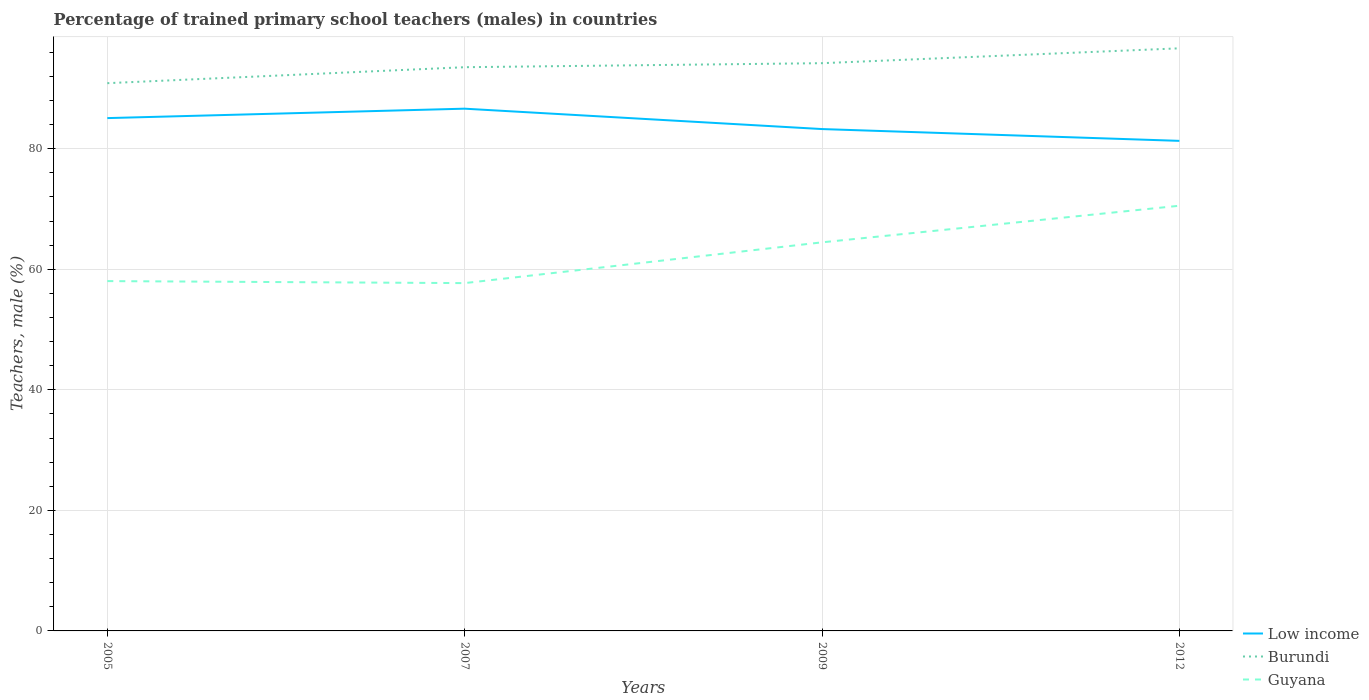Does the line corresponding to Burundi intersect with the line corresponding to Guyana?
Provide a succinct answer. No. Is the number of lines equal to the number of legend labels?
Ensure brevity in your answer.  Yes. Across all years, what is the maximum percentage of trained primary school teachers (males) in Low income?
Offer a very short reply. 81.31. What is the total percentage of trained primary school teachers (males) in Guyana in the graph?
Make the answer very short. -12.5. What is the difference between the highest and the second highest percentage of trained primary school teachers (males) in Burundi?
Provide a short and direct response. 5.78. What is the difference between the highest and the lowest percentage of trained primary school teachers (males) in Low income?
Provide a short and direct response. 2. How many lines are there?
Your response must be concise. 3. How many years are there in the graph?
Make the answer very short. 4. What is the difference between two consecutive major ticks on the Y-axis?
Ensure brevity in your answer.  20. Does the graph contain grids?
Ensure brevity in your answer.  Yes. Where does the legend appear in the graph?
Your answer should be very brief. Bottom right. What is the title of the graph?
Make the answer very short. Percentage of trained primary school teachers (males) in countries. Does "Poland" appear as one of the legend labels in the graph?
Make the answer very short. No. What is the label or title of the X-axis?
Provide a succinct answer. Years. What is the label or title of the Y-axis?
Provide a short and direct response. Teachers, male (%). What is the Teachers, male (%) of Low income in 2005?
Your answer should be compact. 85.08. What is the Teachers, male (%) of Burundi in 2005?
Your response must be concise. 90.88. What is the Teachers, male (%) in Guyana in 2005?
Provide a short and direct response. 58.04. What is the Teachers, male (%) of Low income in 2007?
Ensure brevity in your answer.  86.65. What is the Teachers, male (%) of Burundi in 2007?
Give a very brief answer. 93.53. What is the Teachers, male (%) in Guyana in 2007?
Your answer should be very brief. 57.71. What is the Teachers, male (%) of Low income in 2009?
Make the answer very short. 83.26. What is the Teachers, male (%) of Burundi in 2009?
Your answer should be very brief. 94.19. What is the Teachers, male (%) in Guyana in 2009?
Your answer should be compact. 64.47. What is the Teachers, male (%) in Low income in 2012?
Your answer should be compact. 81.31. What is the Teachers, male (%) of Burundi in 2012?
Make the answer very short. 96.66. What is the Teachers, male (%) in Guyana in 2012?
Ensure brevity in your answer.  70.54. Across all years, what is the maximum Teachers, male (%) of Low income?
Provide a short and direct response. 86.65. Across all years, what is the maximum Teachers, male (%) of Burundi?
Offer a terse response. 96.66. Across all years, what is the maximum Teachers, male (%) in Guyana?
Offer a terse response. 70.54. Across all years, what is the minimum Teachers, male (%) in Low income?
Provide a short and direct response. 81.31. Across all years, what is the minimum Teachers, male (%) in Burundi?
Give a very brief answer. 90.88. Across all years, what is the minimum Teachers, male (%) in Guyana?
Your answer should be compact. 57.71. What is the total Teachers, male (%) of Low income in the graph?
Make the answer very short. 336.3. What is the total Teachers, male (%) in Burundi in the graph?
Your response must be concise. 375.26. What is the total Teachers, male (%) in Guyana in the graph?
Provide a short and direct response. 250.76. What is the difference between the Teachers, male (%) in Low income in 2005 and that in 2007?
Ensure brevity in your answer.  -1.56. What is the difference between the Teachers, male (%) of Burundi in 2005 and that in 2007?
Provide a short and direct response. -2.65. What is the difference between the Teachers, male (%) in Guyana in 2005 and that in 2007?
Give a very brief answer. 0.33. What is the difference between the Teachers, male (%) of Low income in 2005 and that in 2009?
Ensure brevity in your answer.  1.82. What is the difference between the Teachers, male (%) in Burundi in 2005 and that in 2009?
Provide a short and direct response. -3.32. What is the difference between the Teachers, male (%) in Guyana in 2005 and that in 2009?
Your answer should be compact. -6.43. What is the difference between the Teachers, male (%) of Low income in 2005 and that in 2012?
Your answer should be compact. 3.77. What is the difference between the Teachers, male (%) in Burundi in 2005 and that in 2012?
Provide a succinct answer. -5.78. What is the difference between the Teachers, male (%) of Guyana in 2005 and that in 2012?
Provide a succinct answer. -12.5. What is the difference between the Teachers, male (%) of Low income in 2007 and that in 2009?
Your answer should be compact. 3.38. What is the difference between the Teachers, male (%) in Burundi in 2007 and that in 2009?
Provide a succinct answer. -0.67. What is the difference between the Teachers, male (%) in Guyana in 2007 and that in 2009?
Provide a short and direct response. -6.76. What is the difference between the Teachers, male (%) of Low income in 2007 and that in 2012?
Provide a succinct answer. 5.34. What is the difference between the Teachers, male (%) of Burundi in 2007 and that in 2012?
Provide a succinct answer. -3.13. What is the difference between the Teachers, male (%) of Guyana in 2007 and that in 2012?
Your answer should be very brief. -12.84. What is the difference between the Teachers, male (%) in Low income in 2009 and that in 2012?
Your response must be concise. 1.96. What is the difference between the Teachers, male (%) of Burundi in 2009 and that in 2012?
Your response must be concise. -2.47. What is the difference between the Teachers, male (%) in Guyana in 2009 and that in 2012?
Give a very brief answer. -6.07. What is the difference between the Teachers, male (%) in Low income in 2005 and the Teachers, male (%) in Burundi in 2007?
Your answer should be compact. -8.44. What is the difference between the Teachers, male (%) in Low income in 2005 and the Teachers, male (%) in Guyana in 2007?
Give a very brief answer. 27.38. What is the difference between the Teachers, male (%) of Burundi in 2005 and the Teachers, male (%) of Guyana in 2007?
Offer a very short reply. 33.17. What is the difference between the Teachers, male (%) of Low income in 2005 and the Teachers, male (%) of Burundi in 2009?
Give a very brief answer. -9.11. What is the difference between the Teachers, male (%) of Low income in 2005 and the Teachers, male (%) of Guyana in 2009?
Provide a succinct answer. 20.61. What is the difference between the Teachers, male (%) of Burundi in 2005 and the Teachers, male (%) of Guyana in 2009?
Provide a short and direct response. 26.41. What is the difference between the Teachers, male (%) of Low income in 2005 and the Teachers, male (%) of Burundi in 2012?
Offer a very short reply. -11.58. What is the difference between the Teachers, male (%) in Low income in 2005 and the Teachers, male (%) in Guyana in 2012?
Your response must be concise. 14.54. What is the difference between the Teachers, male (%) of Burundi in 2005 and the Teachers, male (%) of Guyana in 2012?
Provide a succinct answer. 20.33. What is the difference between the Teachers, male (%) of Low income in 2007 and the Teachers, male (%) of Burundi in 2009?
Offer a very short reply. -7.55. What is the difference between the Teachers, male (%) in Low income in 2007 and the Teachers, male (%) in Guyana in 2009?
Ensure brevity in your answer.  22.17. What is the difference between the Teachers, male (%) of Burundi in 2007 and the Teachers, male (%) of Guyana in 2009?
Offer a terse response. 29.06. What is the difference between the Teachers, male (%) of Low income in 2007 and the Teachers, male (%) of Burundi in 2012?
Offer a very short reply. -10.02. What is the difference between the Teachers, male (%) of Low income in 2007 and the Teachers, male (%) of Guyana in 2012?
Offer a terse response. 16.1. What is the difference between the Teachers, male (%) of Burundi in 2007 and the Teachers, male (%) of Guyana in 2012?
Offer a very short reply. 22.98. What is the difference between the Teachers, male (%) in Low income in 2009 and the Teachers, male (%) in Burundi in 2012?
Your answer should be very brief. -13.4. What is the difference between the Teachers, male (%) of Low income in 2009 and the Teachers, male (%) of Guyana in 2012?
Your answer should be very brief. 12.72. What is the difference between the Teachers, male (%) of Burundi in 2009 and the Teachers, male (%) of Guyana in 2012?
Keep it short and to the point. 23.65. What is the average Teachers, male (%) in Low income per year?
Your response must be concise. 84.07. What is the average Teachers, male (%) in Burundi per year?
Provide a succinct answer. 93.81. What is the average Teachers, male (%) in Guyana per year?
Offer a terse response. 62.69. In the year 2005, what is the difference between the Teachers, male (%) in Low income and Teachers, male (%) in Burundi?
Make the answer very short. -5.79. In the year 2005, what is the difference between the Teachers, male (%) of Low income and Teachers, male (%) of Guyana?
Offer a terse response. 27.04. In the year 2005, what is the difference between the Teachers, male (%) of Burundi and Teachers, male (%) of Guyana?
Your response must be concise. 32.84. In the year 2007, what is the difference between the Teachers, male (%) in Low income and Teachers, male (%) in Burundi?
Make the answer very short. -6.88. In the year 2007, what is the difference between the Teachers, male (%) of Low income and Teachers, male (%) of Guyana?
Offer a very short reply. 28.94. In the year 2007, what is the difference between the Teachers, male (%) of Burundi and Teachers, male (%) of Guyana?
Offer a very short reply. 35.82. In the year 2009, what is the difference between the Teachers, male (%) of Low income and Teachers, male (%) of Burundi?
Provide a succinct answer. -10.93. In the year 2009, what is the difference between the Teachers, male (%) in Low income and Teachers, male (%) in Guyana?
Provide a short and direct response. 18.79. In the year 2009, what is the difference between the Teachers, male (%) of Burundi and Teachers, male (%) of Guyana?
Ensure brevity in your answer.  29.72. In the year 2012, what is the difference between the Teachers, male (%) in Low income and Teachers, male (%) in Burundi?
Ensure brevity in your answer.  -15.35. In the year 2012, what is the difference between the Teachers, male (%) in Low income and Teachers, male (%) in Guyana?
Your answer should be very brief. 10.76. In the year 2012, what is the difference between the Teachers, male (%) of Burundi and Teachers, male (%) of Guyana?
Offer a terse response. 26.12. What is the ratio of the Teachers, male (%) in Burundi in 2005 to that in 2007?
Give a very brief answer. 0.97. What is the ratio of the Teachers, male (%) of Low income in 2005 to that in 2009?
Offer a terse response. 1.02. What is the ratio of the Teachers, male (%) in Burundi in 2005 to that in 2009?
Your response must be concise. 0.96. What is the ratio of the Teachers, male (%) of Guyana in 2005 to that in 2009?
Keep it short and to the point. 0.9. What is the ratio of the Teachers, male (%) of Low income in 2005 to that in 2012?
Provide a succinct answer. 1.05. What is the ratio of the Teachers, male (%) of Burundi in 2005 to that in 2012?
Your response must be concise. 0.94. What is the ratio of the Teachers, male (%) in Guyana in 2005 to that in 2012?
Keep it short and to the point. 0.82. What is the ratio of the Teachers, male (%) of Low income in 2007 to that in 2009?
Provide a succinct answer. 1.04. What is the ratio of the Teachers, male (%) of Guyana in 2007 to that in 2009?
Provide a succinct answer. 0.9. What is the ratio of the Teachers, male (%) of Low income in 2007 to that in 2012?
Give a very brief answer. 1.07. What is the ratio of the Teachers, male (%) of Burundi in 2007 to that in 2012?
Ensure brevity in your answer.  0.97. What is the ratio of the Teachers, male (%) of Guyana in 2007 to that in 2012?
Make the answer very short. 0.82. What is the ratio of the Teachers, male (%) of Low income in 2009 to that in 2012?
Offer a very short reply. 1.02. What is the ratio of the Teachers, male (%) in Burundi in 2009 to that in 2012?
Provide a succinct answer. 0.97. What is the ratio of the Teachers, male (%) of Guyana in 2009 to that in 2012?
Your answer should be compact. 0.91. What is the difference between the highest and the second highest Teachers, male (%) of Low income?
Offer a terse response. 1.56. What is the difference between the highest and the second highest Teachers, male (%) of Burundi?
Ensure brevity in your answer.  2.47. What is the difference between the highest and the second highest Teachers, male (%) of Guyana?
Ensure brevity in your answer.  6.07. What is the difference between the highest and the lowest Teachers, male (%) of Low income?
Your answer should be compact. 5.34. What is the difference between the highest and the lowest Teachers, male (%) in Burundi?
Your response must be concise. 5.78. What is the difference between the highest and the lowest Teachers, male (%) of Guyana?
Keep it short and to the point. 12.84. 